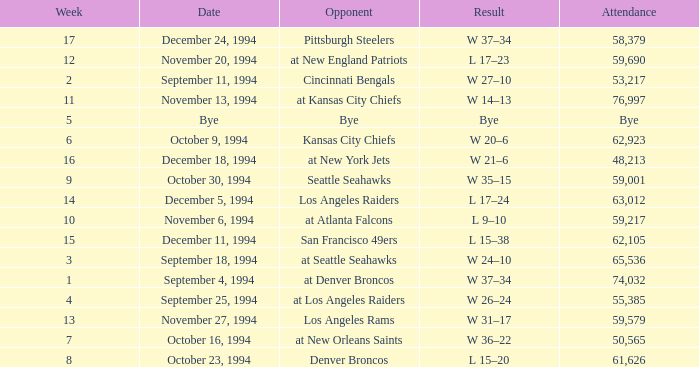In the game where they played the Pittsburgh Steelers, what was the attendance? 58379.0. 